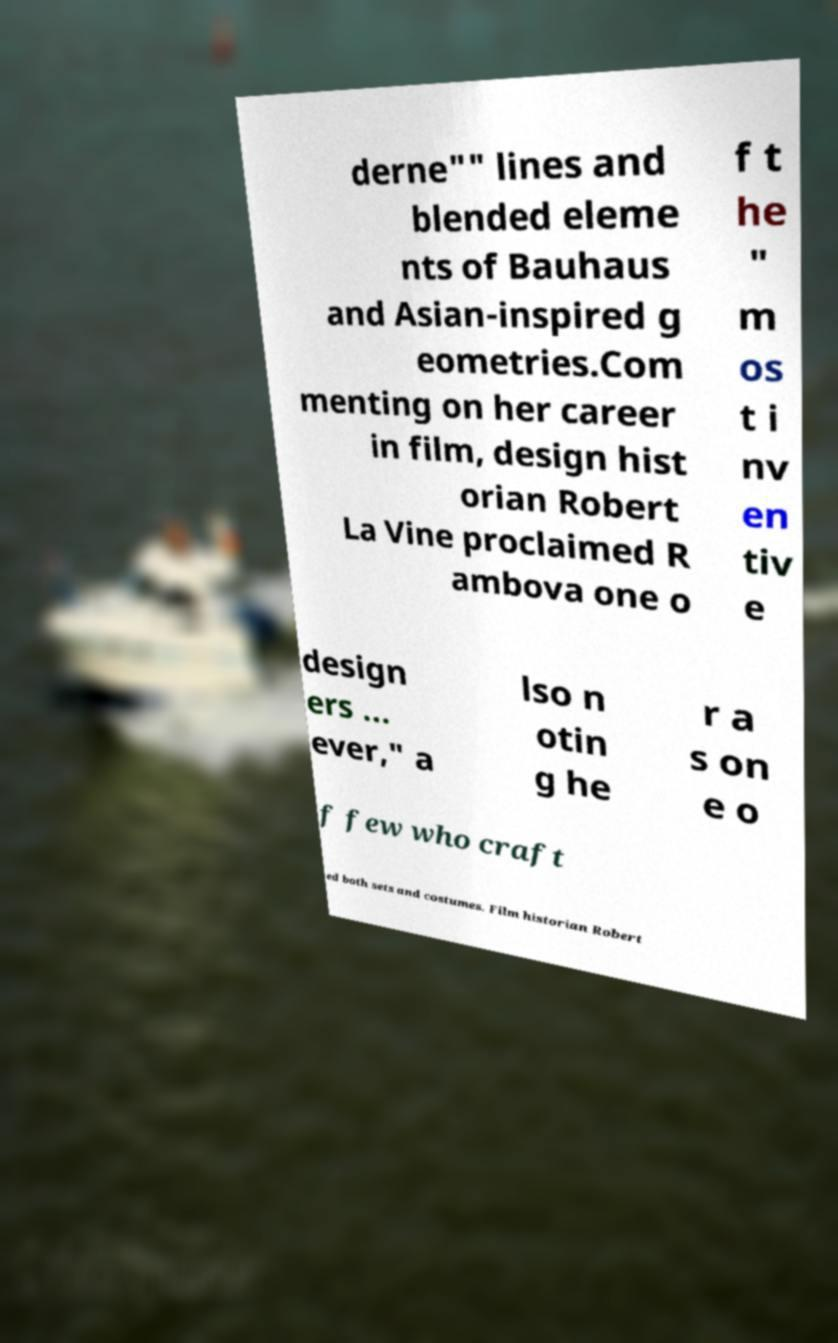Please read and relay the text visible in this image. What does it say? derne"" lines and blended eleme nts of Bauhaus and Asian-inspired g eometries.Com menting on her career in film, design hist orian Robert La Vine proclaimed R ambova one o f t he " m os t i nv en tiv e design ers ... ever," a lso n otin g he r a s on e o f few who craft ed both sets and costumes. Film historian Robert 